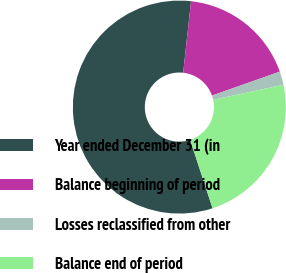<chart> <loc_0><loc_0><loc_500><loc_500><pie_chart><fcel>Year ended December 31 (in<fcel>Balance beginning of period<fcel>Losses reclassified from other<fcel>Balance end of period<nl><fcel>56.79%<fcel>17.85%<fcel>2.03%<fcel>23.32%<nl></chart> 